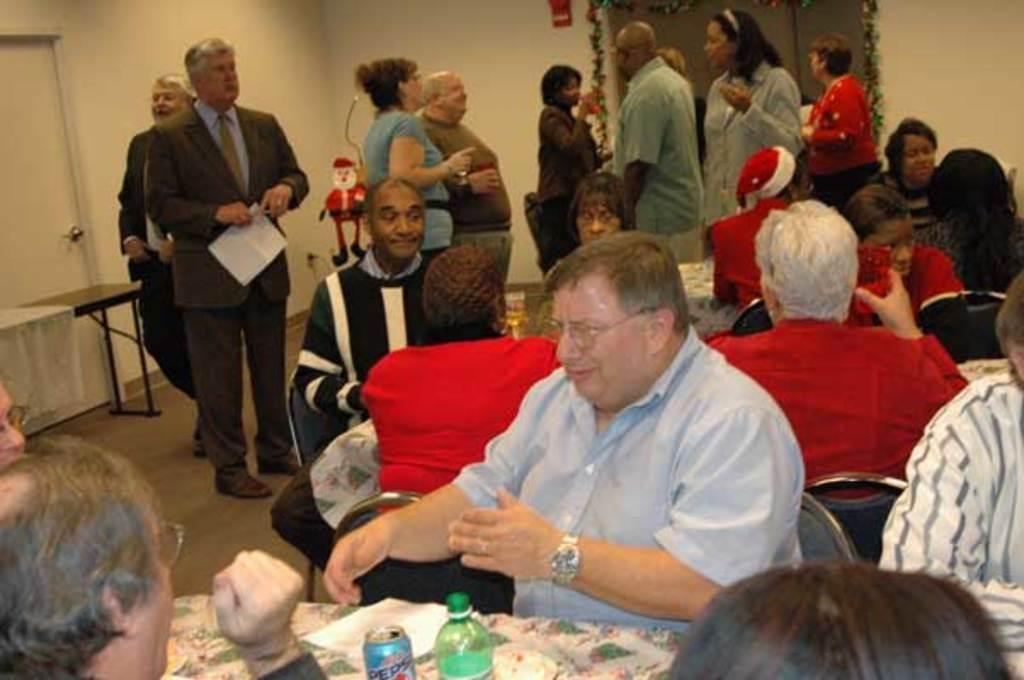Please provide a concise description of this image. In the picture we can see some people sitting on the chairs near the tables and on the table, we can see some bottle, tin and paper and in the background, we can see some people are standing and in the wall we can see a door and a table near it. 